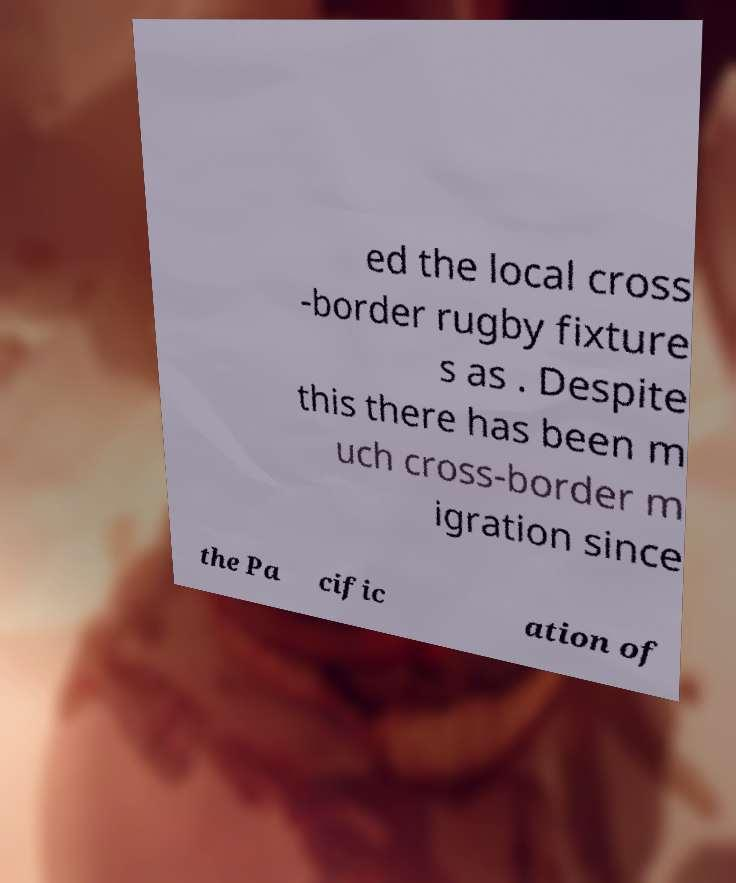Please identify and transcribe the text found in this image. ed the local cross -border rugby fixture s as . Despite this there has been m uch cross-border m igration since the Pa cific ation of 